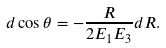<formula> <loc_0><loc_0><loc_500><loc_500>d \cos { \theta } = - \frac { R } { 2 E _ { 1 } E _ { 3 } } d R .</formula> 